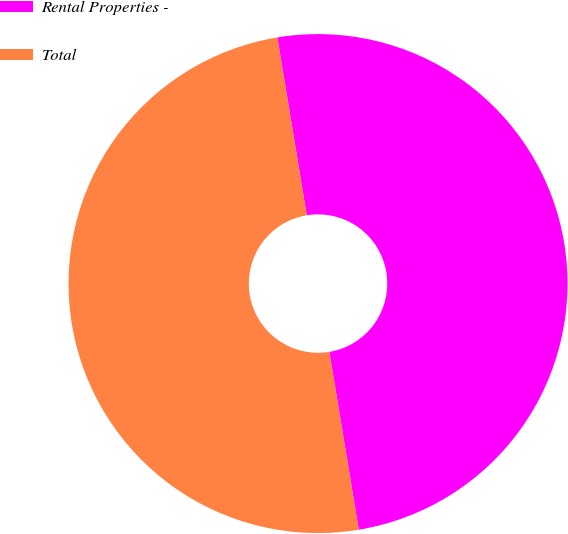Convert chart. <chart><loc_0><loc_0><loc_500><loc_500><pie_chart><fcel>Rental Properties -<fcel>Total<nl><fcel>50.0%<fcel>50.0%<nl></chart> 